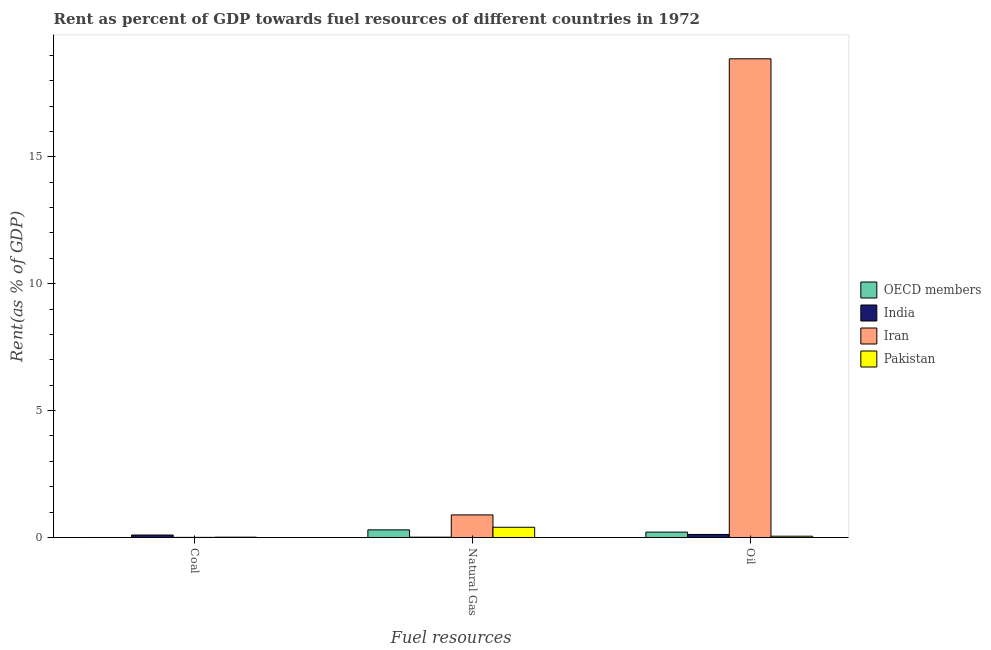Are the number of bars per tick equal to the number of legend labels?
Your answer should be very brief. Yes. What is the label of the 2nd group of bars from the left?
Provide a succinct answer. Natural Gas. What is the rent towards oil in India?
Your answer should be compact. 0.12. Across all countries, what is the maximum rent towards natural gas?
Your answer should be very brief. 0.89. Across all countries, what is the minimum rent towards oil?
Make the answer very short. 0.05. In which country was the rent towards natural gas maximum?
Your response must be concise. Iran. In which country was the rent towards coal minimum?
Make the answer very short. OECD members. What is the total rent towards natural gas in the graph?
Your answer should be compact. 1.61. What is the difference between the rent towards oil in Iran and that in India?
Your answer should be compact. 18.74. What is the difference between the rent towards coal in Iran and the rent towards natural gas in India?
Offer a terse response. -0.01. What is the average rent towards oil per country?
Your response must be concise. 4.81. What is the difference between the rent towards coal and rent towards natural gas in Pakistan?
Keep it short and to the point. -0.39. In how many countries, is the rent towards oil greater than 14 %?
Your answer should be compact. 1. What is the ratio of the rent towards natural gas in Pakistan to that in India?
Offer a terse response. 32.92. Is the difference between the rent towards coal in Pakistan and OECD members greater than the difference between the rent towards oil in Pakistan and OECD members?
Make the answer very short. Yes. What is the difference between the highest and the second highest rent towards oil?
Your answer should be compact. 18.65. What is the difference between the highest and the lowest rent towards natural gas?
Offer a very short reply. 0.88. In how many countries, is the rent towards coal greater than the average rent towards coal taken over all countries?
Give a very brief answer. 1. What does the 2nd bar from the left in Oil represents?
Make the answer very short. India. How many bars are there?
Your answer should be very brief. 12. What is the difference between two consecutive major ticks on the Y-axis?
Provide a succinct answer. 5. Are the values on the major ticks of Y-axis written in scientific E-notation?
Ensure brevity in your answer.  No. Does the graph contain any zero values?
Give a very brief answer. No. How are the legend labels stacked?
Give a very brief answer. Vertical. What is the title of the graph?
Provide a short and direct response. Rent as percent of GDP towards fuel resources of different countries in 1972. What is the label or title of the X-axis?
Provide a short and direct response. Fuel resources. What is the label or title of the Y-axis?
Provide a short and direct response. Rent(as % of GDP). What is the Rent(as % of GDP) of OECD members in Coal?
Ensure brevity in your answer.  2.27630170157113e-6. What is the Rent(as % of GDP) in India in Coal?
Ensure brevity in your answer.  0.1. What is the Rent(as % of GDP) in Iran in Coal?
Offer a very short reply. 0. What is the Rent(as % of GDP) of Pakistan in Coal?
Offer a terse response. 0.01. What is the Rent(as % of GDP) of OECD members in Natural Gas?
Offer a terse response. 0.3. What is the Rent(as % of GDP) in India in Natural Gas?
Provide a succinct answer. 0.01. What is the Rent(as % of GDP) of Iran in Natural Gas?
Make the answer very short. 0.89. What is the Rent(as % of GDP) of Pakistan in Natural Gas?
Make the answer very short. 0.4. What is the Rent(as % of GDP) in OECD members in Oil?
Your response must be concise. 0.21. What is the Rent(as % of GDP) in India in Oil?
Your response must be concise. 0.12. What is the Rent(as % of GDP) of Iran in Oil?
Keep it short and to the point. 18.86. What is the Rent(as % of GDP) of Pakistan in Oil?
Your answer should be very brief. 0.05. Across all Fuel resources, what is the maximum Rent(as % of GDP) in OECD members?
Provide a succinct answer. 0.3. Across all Fuel resources, what is the maximum Rent(as % of GDP) in India?
Provide a succinct answer. 0.12. Across all Fuel resources, what is the maximum Rent(as % of GDP) of Iran?
Offer a terse response. 18.86. Across all Fuel resources, what is the maximum Rent(as % of GDP) of Pakistan?
Your response must be concise. 0.4. Across all Fuel resources, what is the minimum Rent(as % of GDP) in OECD members?
Ensure brevity in your answer.  2.27630170157113e-6. Across all Fuel resources, what is the minimum Rent(as % of GDP) in India?
Make the answer very short. 0.01. Across all Fuel resources, what is the minimum Rent(as % of GDP) of Iran?
Provide a succinct answer. 0. Across all Fuel resources, what is the minimum Rent(as % of GDP) of Pakistan?
Ensure brevity in your answer.  0.01. What is the total Rent(as % of GDP) of OECD members in the graph?
Give a very brief answer. 0.51. What is the total Rent(as % of GDP) in India in the graph?
Offer a terse response. 0.23. What is the total Rent(as % of GDP) of Iran in the graph?
Offer a very short reply. 19.76. What is the total Rent(as % of GDP) of Pakistan in the graph?
Provide a succinct answer. 0.47. What is the difference between the Rent(as % of GDP) in OECD members in Coal and that in Natural Gas?
Your response must be concise. -0.3. What is the difference between the Rent(as % of GDP) of India in Coal and that in Natural Gas?
Keep it short and to the point. 0.09. What is the difference between the Rent(as % of GDP) in Iran in Coal and that in Natural Gas?
Keep it short and to the point. -0.89. What is the difference between the Rent(as % of GDP) in Pakistan in Coal and that in Natural Gas?
Provide a short and direct response. -0.39. What is the difference between the Rent(as % of GDP) in OECD members in Coal and that in Oil?
Ensure brevity in your answer.  -0.21. What is the difference between the Rent(as % of GDP) of India in Coal and that in Oil?
Keep it short and to the point. -0.02. What is the difference between the Rent(as % of GDP) in Iran in Coal and that in Oil?
Give a very brief answer. -18.86. What is the difference between the Rent(as % of GDP) in Pakistan in Coal and that in Oil?
Provide a short and direct response. -0.04. What is the difference between the Rent(as % of GDP) of OECD members in Natural Gas and that in Oil?
Provide a short and direct response. 0.09. What is the difference between the Rent(as % of GDP) in India in Natural Gas and that in Oil?
Your answer should be compact. -0.11. What is the difference between the Rent(as % of GDP) in Iran in Natural Gas and that in Oil?
Offer a terse response. -17.97. What is the difference between the Rent(as % of GDP) of Pakistan in Natural Gas and that in Oil?
Your answer should be compact. 0.35. What is the difference between the Rent(as % of GDP) of OECD members in Coal and the Rent(as % of GDP) of India in Natural Gas?
Provide a short and direct response. -0.01. What is the difference between the Rent(as % of GDP) in OECD members in Coal and the Rent(as % of GDP) in Iran in Natural Gas?
Make the answer very short. -0.89. What is the difference between the Rent(as % of GDP) of OECD members in Coal and the Rent(as % of GDP) of Pakistan in Natural Gas?
Your answer should be very brief. -0.4. What is the difference between the Rent(as % of GDP) of India in Coal and the Rent(as % of GDP) of Iran in Natural Gas?
Offer a terse response. -0.79. What is the difference between the Rent(as % of GDP) in India in Coal and the Rent(as % of GDP) in Pakistan in Natural Gas?
Offer a terse response. -0.31. What is the difference between the Rent(as % of GDP) of Iran in Coal and the Rent(as % of GDP) of Pakistan in Natural Gas?
Ensure brevity in your answer.  -0.4. What is the difference between the Rent(as % of GDP) of OECD members in Coal and the Rent(as % of GDP) of India in Oil?
Your answer should be compact. -0.12. What is the difference between the Rent(as % of GDP) of OECD members in Coal and the Rent(as % of GDP) of Iran in Oil?
Offer a very short reply. -18.86. What is the difference between the Rent(as % of GDP) of OECD members in Coal and the Rent(as % of GDP) of Pakistan in Oil?
Keep it short and to the point. -0.05. What is the difference between the Rent(as % of GDP) in India in Coal and the Rent(as % of GDP) in Iran in Oil?
Give a very brief answer. -18.76. What is the difference between the Rent(as % of GDP) in India in Coal and the Rent(as % of GDP) in Pakistan in Oil?
Make the answer very short. 0.05. What is the difference between the Rent(as % of GDP) in Iran in Coal and the Rent(as % of GDP) in Pakistan in Oil?
Provide a succinct answer. -0.05. What is the difference between the Rent(as % of GDP) of OECD members in Natural Gas and the Rent(as % of GDP) of India in Oil?
Provide a short and direct response. 0.18. What is the difference between the Rent(as % of GDP) in OECD members in Natural Gas and the Rent(as % of GDP) in Iran in Oil?
Give a very brief answer. -18.56. What is the difference between the Rent(as % of GDP) of OECD members in Natural Gas and the Rent(as % of GDP) of Pakistan in Oil?
Provide a short and direct response. 0.25. What is the difference between the Rent(as % of GDP) of India in Natural Gas and the Rent(as % of GDP) of Iran in Oil?
Your response must be concise. -18.85. What is the difference between the Rent(as % of GDP) of India in Natural Gas and the Rent(as % of GDP) of Pakistan in Oil?
Ensure brevity in your answer.  -0.04. What is the difference between the Rent(as % of GDP) in Iran in Natural Gas and the Rent(as % of GDP) in Pakistan in Oil?
Provide a succinct answer. 0.84. What is the average Rent(as % of GDP) in OECD members per Fuel resources?
Offer a very short reply. 0.17. What is the average Rent(as % of GDP) in India per Fuel resources?
Make the answer very short. 0.08. What is the average Rent(as % of GDP) of Iran per Fuel resources?
Ensure brevity in your answer.  6.59. What is the average Rent(as % of GDP) in Pakistan per Fuel resources?
Your response must be concise. 0.16. What is the difference between the Rent(as % of GDP) of OECD members and Rent(as % of GDP) of India in Coal?
Your answer should be very brief. -0.1. What is the difference between the Rent(as % of GDP) in OECD members and Rent(as % of GDP) in Iran in Coal?
Keep it short and to the point. -0. What is the difference between the Rent(as % of GDP) in OECD members and Rent(as % of GDP) in Pakistan in Coal?
Your response must be concise. -0.01. What is the difference between the Rent(as % of GDP) of India and Rent(as % of GDP) of Iran in Coal?
Your answer should be compact. 0.09. What is the difference between the Rent(as % of GDP) in India and Rent(as % of GDP) in Pakistan in Coal?
Provide a succinct answer. 0.09. What is the difference between the Rent(as % of GDP) of Iran and Rent(as % of GDP) of Pakistan in Coal?
Provide a succinct answer. -0.01. What is the difference between the Rent(as % of GDP) of OECD members and Rent(as % of GDP) of India in Natural Gas?
Make the answer very short. 0.29. What is the difference between the Rent(as % of GDP) of OECD members and Rent(as % of GDP) of Iran in Natural Gas?
Provide a succinct answer. -0.59. What is the difference between the Rent(as % of GDP) of OECD members and Rent(as % of GDP) of Pakistan in Natural Gas?
Offer a terse response. -0.1. What is the difference between the Rent(as % of GDP) of India and Rent(as % of GDP) of Iran in Natural Gas?
Ensure brevity in your answer.  -0.88. What is the difference between the Rent(as % of GDP) of India and Rent(as % of GDP) of Pakistan in Natural Gas?
Offer a very short reply. -0.39. What is the difference between the Rent(as % of GDP) of Iran and Rent(as % of GDP) of Pakistan in Natural Gas?
Provide a succinct answer. 0.49. What is the difference between the Rent(as % of GDP) in OECD members and Rent(as % of GDP) in India in Oil?
Provide a short and direct response. 0.09. What is the difference between the Rent(as % of GDP) in OECD members and Rent(as % of GDP) in Iran in Oil?
Your answer should be compact. -18.65. What is the difference between the Rent(as % of GDP) of OECD members and Rent(as % of GDP) of Pakistan in Oil?
Give a very brief answer. 0.16. What is the difference between the Rent(as % of GDP) of India and Rent(as % of GDP) of Iran in Oil?
Offer a very short reply. -18.74. What is the difference between the Rent(as % of GDP) in India and Rent(as % of GDP) in Pakistan in Oil?
Ensure brevity in your answer.  0.07. What is the difference between the Rent(as % of GDP) of Iran and Rent(as % of GDP) of Pakistan in Oil?
Provide a short and direct response. 18.81. What is the ratio of the Rent(as % of GDP) in OECD members in Coal to that in Natural Gas?
Make the answer very short. 0. What is the ratio of the Rent(as % of GDP) in India in Coal to that in Natural Gas?
Give a very brief answer. 7.95. What is the ratio of the Rent(as % of GDP) in Iran in Coal to that in Natural Gas?
Give a very brief answer. 0. What is the ratio of the Rent(as % of GDP) in Pakistan in Coal to that in Natural Gas?
Ensure brevity in your answer.  0.03. What is the ratio of the Rent(as % of GDP) of OECD members in Coal to that in Oil?
Give a very brief answer. 0. What is the ratio of the Rent(as % of GDP) in India in Coal to that in Oil?
Your answer should be compact. 0.81. What is the ratio of the Rent(as % of GDP) in Iran in Coal to that in Oil?
Your answer should be compact. 0. What is the ratio of the Rent(as % of GDP) in Pakistan in Coal to that in Oil?
Offer a terse response. 0.24. What is the ratio of the Rent(as % of GDP) of OECD members in Natural Gas to that in Oil?
Make the answer very short. 1.42. What is the ratio of the Rent(as % of GDP) in India in Natural Gas to that in Oil?
Give a very brief answer. 0.1. What is the ratio of the Rent(as % of GDP) in Iran in Natural Gas to that in Oil?
Keep it short and to the point. 0.05. What is the ratio of the Rent(as % of GDP) of Pakistan in Natural Gas to that in Oil?
Make the answer very short. 7.93. What is the difference between the highest and the second highest Rent(as % of GDP) in OECD members?
Your answer should be very brief. 0.09. What is the difference between the highest and the second highest Rent(as % of GDP) in India?
Your answer should be very brief. 0.02. What is the difference between the highest and the second highest Rent(as % of GDP) in Iran?
Keep it short and to the point. 17.97. What is the difference between the highest and the second highest Rent(as % of GDP) of Pakistan?
Your answer should be very brief. 0.35. What is the difference between the highest and the lowest Rent(as % of GDP) of OECD members?
Your answer should be compact. 0.3. What is the difference between the highest and the lowest Rent(as % of GDP) of India?
Ensure brevity in your answer.  0.11. What is the difference between the highest and the lowest Rent(as % of GDP) of Iran?
Offer a very short reply. 18.86. What is the difference between the highest and the lowest Rent(as % of GDP) of Pakistan?
Make the answer very short. 0.39. 